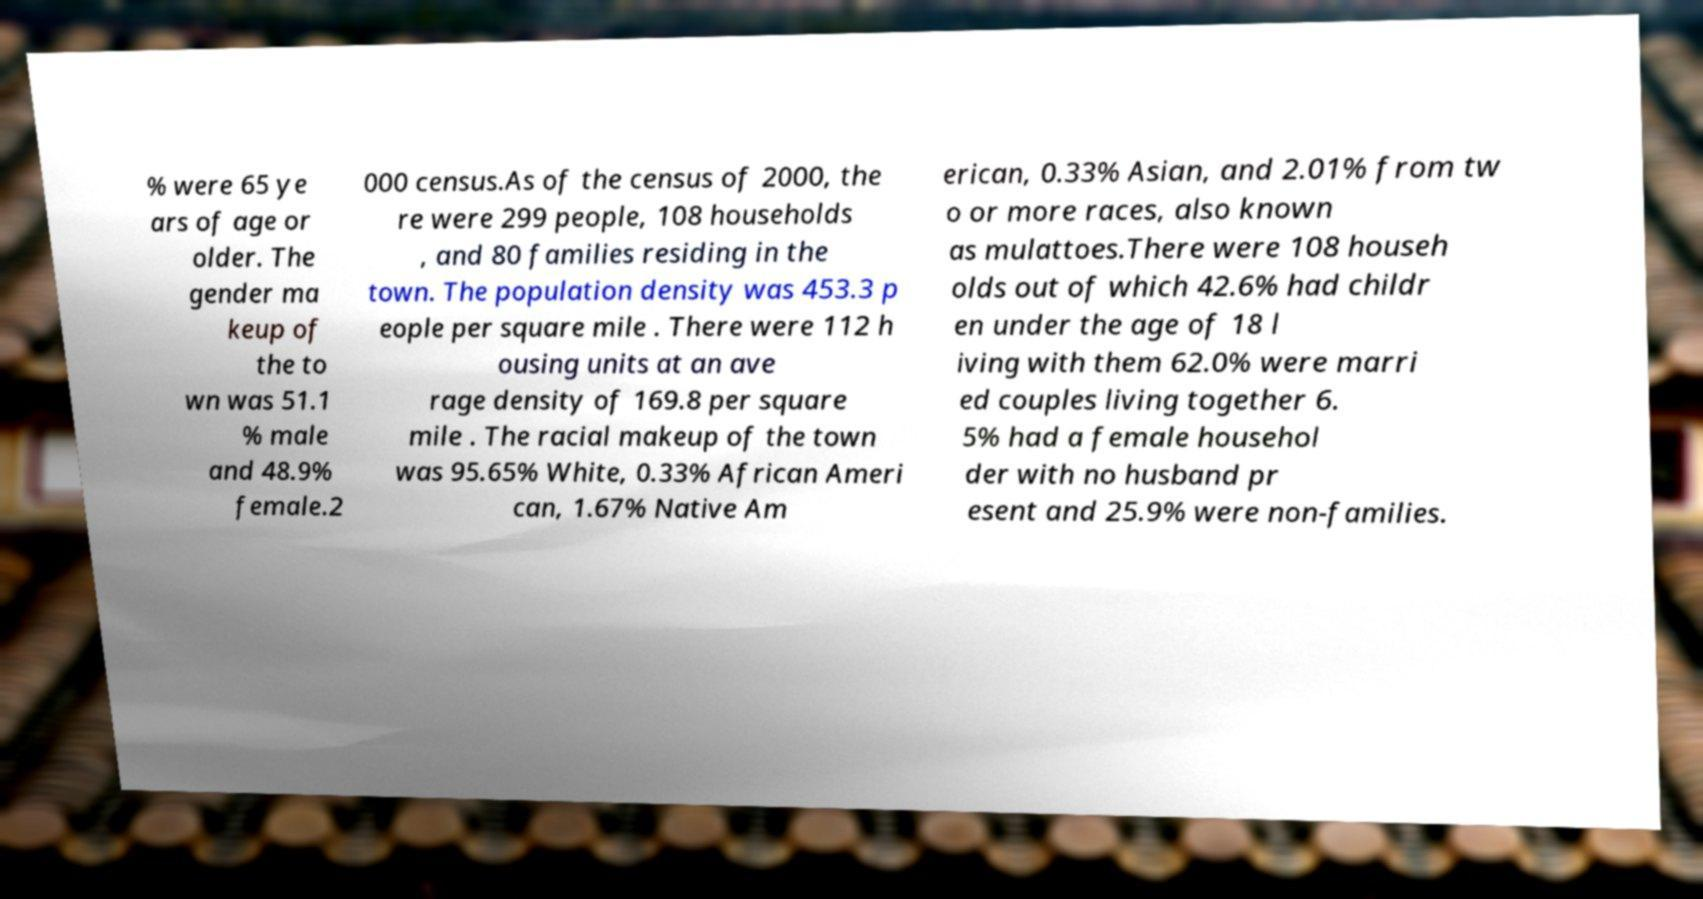Can you read and provide the text displayed in the image?This photo seems to have some interesting text. Can you extract and type it out for me? % were 65 ye ars of age or older. The gender ma keup of the to wn was 51.1 % male and 48.9% female.2 000 census.As of the census of 2000, the re were 299 people, 108 households , and 80 families residing in the town. The population density was 453.3 p eople per square mile . There were 112 h ousing units at an ave rage density of 169.8 per square mile . The racial makeup of the town was 95.65% White, 0.33% African Ameri can, 1.67% Native Am erican, 0.33% Asian, and 2.01% from tw o or more races, also known as mulattoes.There were 108 househ olds out of which 42.6% had childr en under the age of 18 l iving with them 62.0% were marri ed couples living together 6. 5% had a female househol der with no husband pr esent and 25.9% were non-families. 